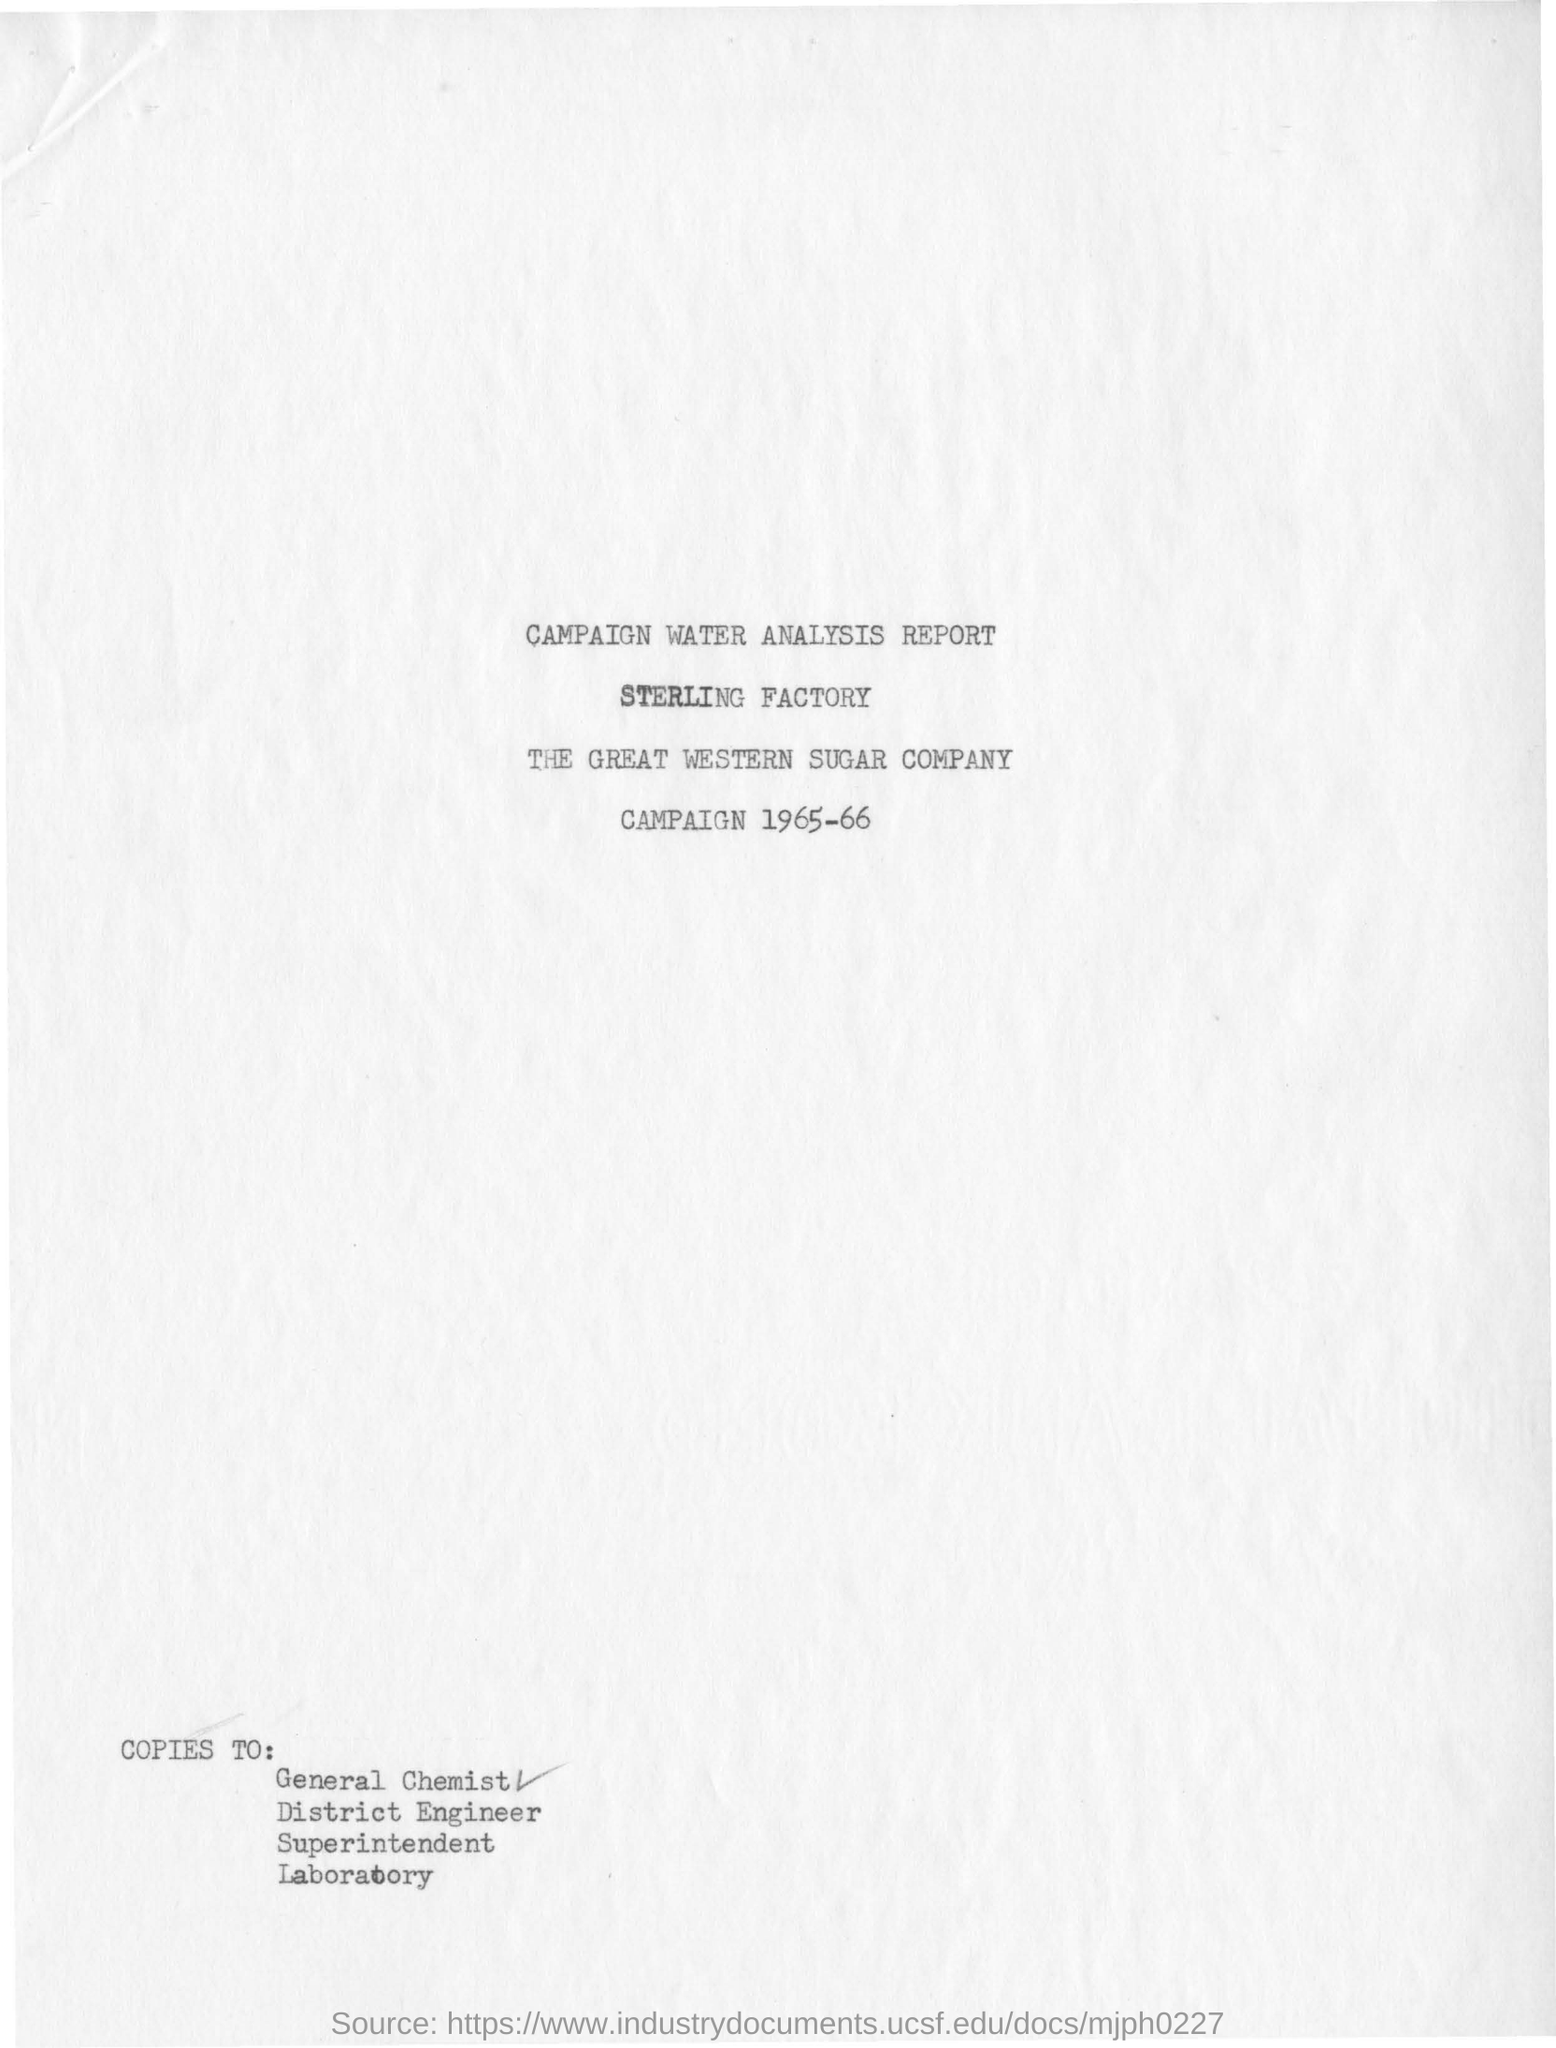Indicate a few pertinent items in this graphic. The campaign was conducted in the years 1965-1966. The company is named The Great Western Sugar Company. The name of the factory is the Sterling factory. 